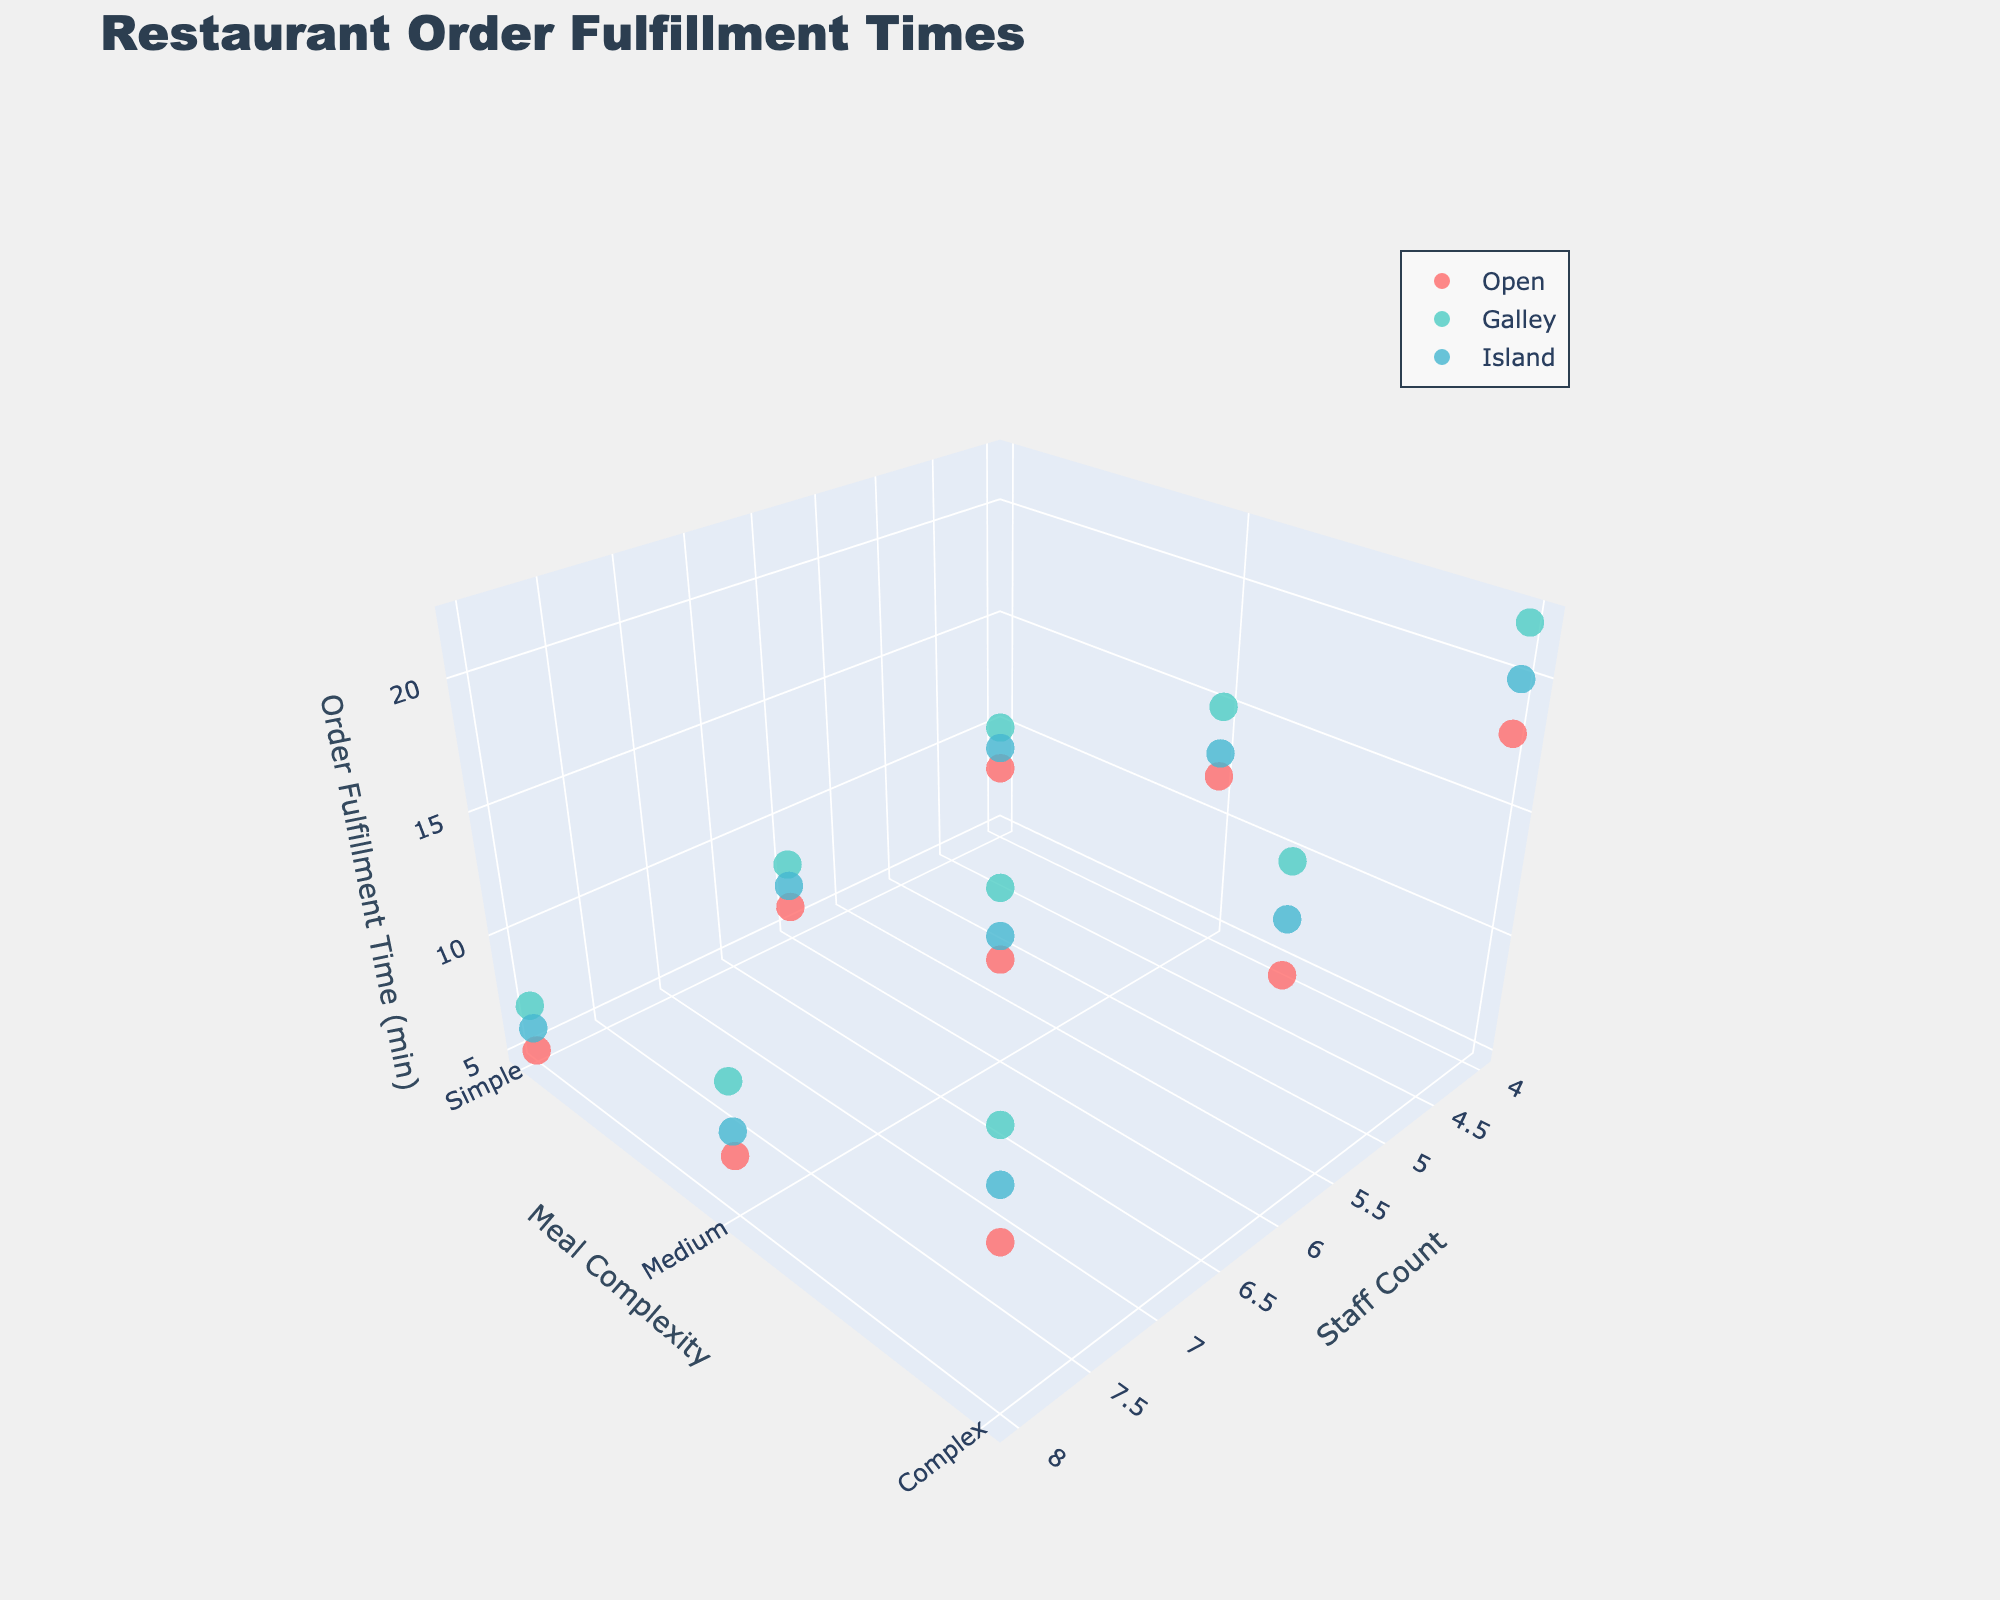How many different kitchen layouts are shown in the plot? The plot legend displays the distinct categories, each representing a kitchen layout. By counting the legend entries, you determine the number of layouts.
Answer: Three What's the title of the figure? The title is typically displayed prominently at the top of the figure.
Answer: Restaurant Order Fulfillment Times Which kitchen layout has the highest order fulfillment time for complex meals? By examining the legend colors in the plot and observing the z-axis values corresponding to complex meals, you can identify which layout reaches the highest point.
Answer: Galley For an open kitchen layout with 6 staff members and medium complexity, what is the order fulfillment time? Locate the appropriate layout by color in the legend. Match the x-axis (staff count = 6) and y-axis (meal complexity = Medium). The z-axis gives the fulfillment time.
Answer: 9 minutes What's the difference in order fulfillment time for a simple meal between a kitchen with 4 staff members and one with 8 staff members, both using an island layout? Identify the z-axis values for simple meals with staff counts of 4 and 8 within the island layout. Subtract the lower time from the higher time.
Answer: 3 minutes Which kitchen layout tends to have the shortest order fulfillment times overall? Observe the general z-axis (pending on the lowest points) regions for each layout color to determine the overall shortest times.
Answer: Open Are meals with higher complexity taking significantly longer to fulfill in all kitchen layouts? Compare the z-axis values across different complexity levels for each kitchen layout to see if there's a consistent increase in time with complexity.
Answer: Yes How does increasing the number of staff from 4 to 8 affect order fulfillment times across different kitchen layouts for medium complexity meals? Track changes in z-axis values for medium meals while increasing the x-axis (staff count), for each layout based on the legend colors.
Answer: Order fulfillment times decrease as staff increases What is the relative performance of an island layout versus a galley layout when dealing with complex meals and 4 staff members? Compare the z-axis values for complex meals (y-axis) with 4 staff (x-axis) between the island and galley layouts' data points.
Answer: Island is slightly faster How does meal complexity affect order fulfillment time in an open layout kitchen with 8 staff members? Observe the z-axis values for an open layout with 8 staff while shifting from simple to complex meals along the y-axis to note the trend.
Answer: Time increases with complexity 